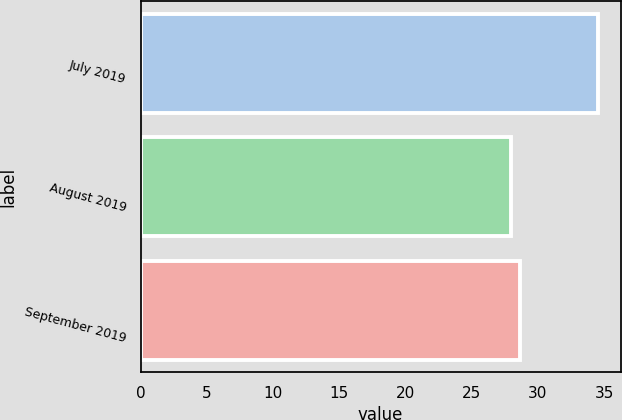Convert chart. <chart><loc_0><loc_0><loc_500><loc_500><bar_chart><fcel>July 2019<fcel>August 2019<fcel>September 2019<nl><fcel>34.52<fcel>27.97<fcel>28.62<nl></chart> 